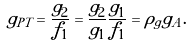Convert formula to latex. <formula><loc_0><loc_0><loc_500><loc_500>g _ { P T } = \frac { g _ { 2 } } { f _ { 1 } } = \frac { g _ { 2 } } { g _ { 1 } } \frac { g _ { 1 } } { f _ { 1 } } = \rho _ { g } g _ { A } .</formula> 